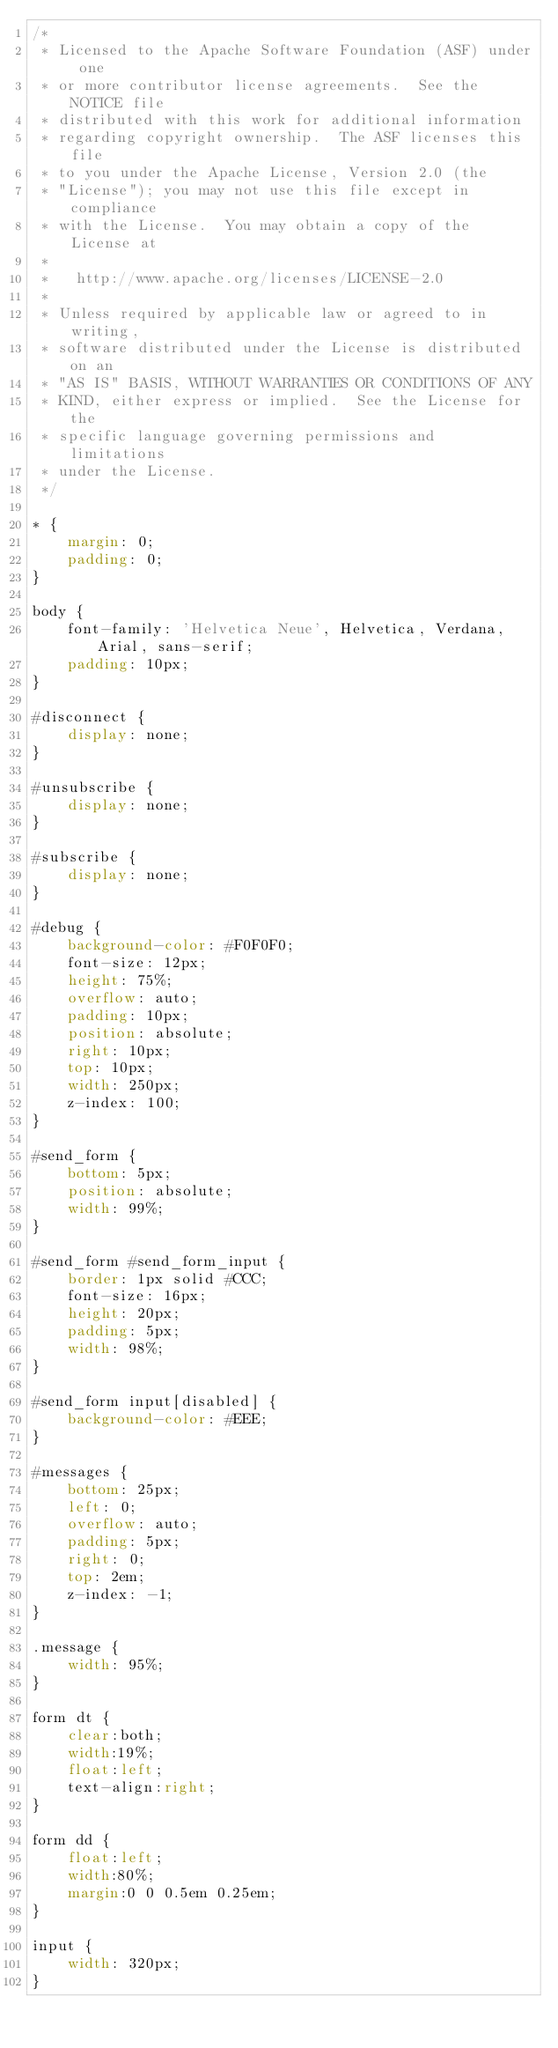<code> <loc_0><loc_0><loc_500><loc_500><_CSS_>/*
 * Licensed to the Apache Software Foundation (ASF) under one
 * or more contributor license agreements.  See the NOTICE file
 * distributed with this work for additional information
 * regarding copyright ownership.  The ASF licenses this file
 * to you under the Apache License, Version 2.0 (the
 * "License"); you may not use this file except in compliance
 * with the License.  You may obtain a copy of the License at
 * 
 *   http://www.apache.org/licenses/LICENSE-2.0
 * 
 * Unless required by applicable law or agreed to in writing,
 * software distributed under the License is distributed on an
 * "AS IS" BASIS, WITHOUT WARRANTIES OR CONDITIONS OF ANY
 * KIND, either express or implied.  See the License for the
 * specific language governing permissions and limitations
 * under the License.
 */

* {
    margin: 0;
    padding: 0;
}

body {
    font-family: 'Helvetica Neue', Helvetica, Verdana, Arial, sans-serif;
    padding: 10px;
}

#disconnect {
    display: none;
}

#unsubscribe {
    display: none;
}

#subscribe {
    display: none;
}

#debug {
    background-color: #F0F0F0;
    font-size: 12px;
    height: 75%;
    overflow: auto;
    padding: 10px;
    position: absolute;
    right: 10px;
    top: 10px;
    width: 250px;
    z-index: 100;
}

#send_form {
    bottom: 5px;
    position: absolute;
    width: 99%;
}

#send_form #send_form_input {
    border: 1px solid #CCC;
    font-size: 16px;
    height: 20px;
    padding: 5px;
    width: 98%;
}

#send_form input[disabled] {
    background-color: #EEE;
}

#messages {
    bottom: 25px;
    left: 0;
    overflow: auto;
    padding: 5px;
    right: 0;
    top: 2em;
    z-index: -1;
}

.message {
    width: 95%;
}

form dt {
    clear:both;
    width:19%;
    float:left;
    text-align:right;
}

form dd {
    float:left;
    width:80%;
    margin:0 0 0.5em 0.25em;
}

input {
    width: 320px;
}
</code> 